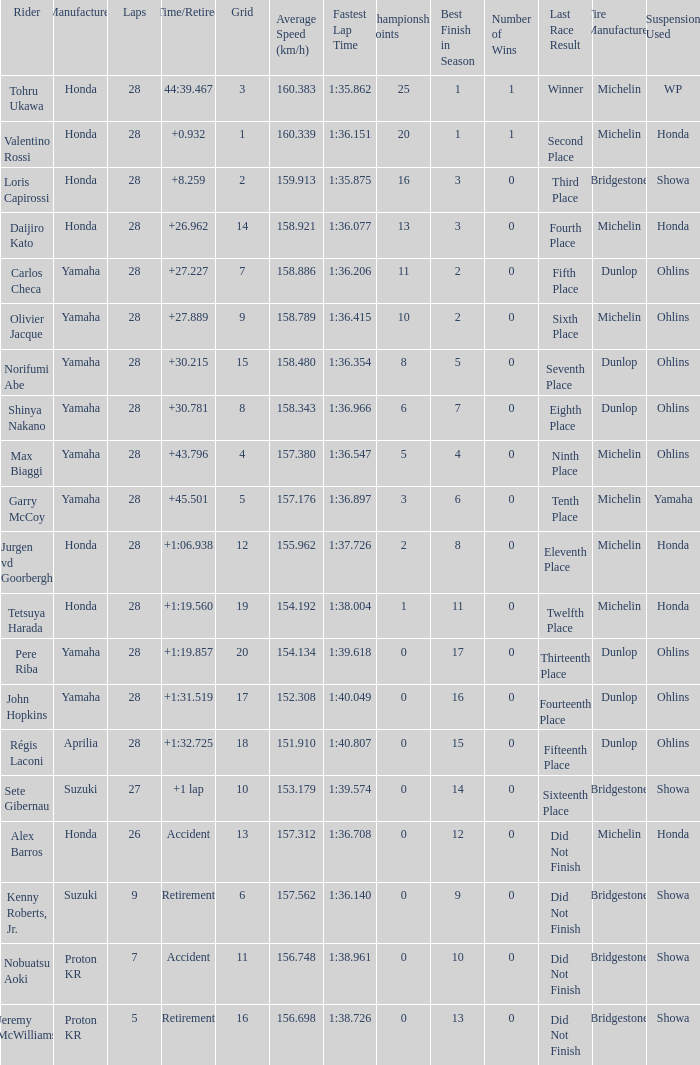How many laps did pere riba ride? 28.0. 